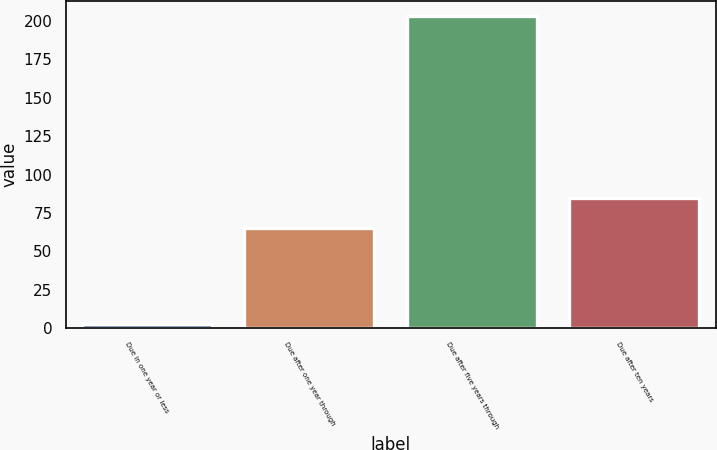Convert chart. <chart><loc_0><loc_0><loc_500><loc_500><bar_chart><fcel>Due in one year or less<fcel>Due after one year through<fcel>Due after five years through<fcel>Due after ten years<nl><fcel>3<fcel>65<fcel>203<fcel>85<nl></chart> 